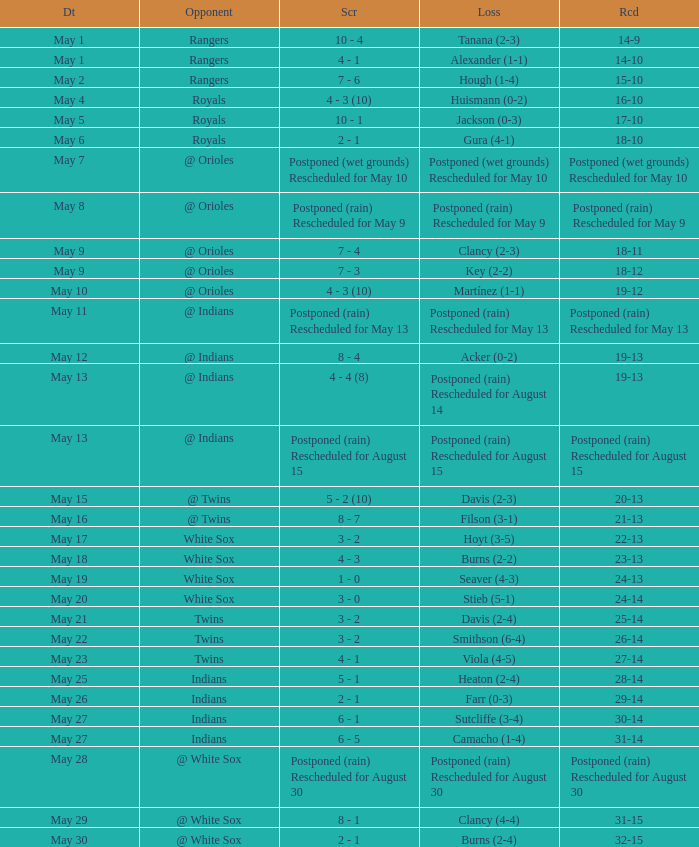What was the game's outcome against the indians when camacho experienced a loss with a 1-4 record? 31-14. 